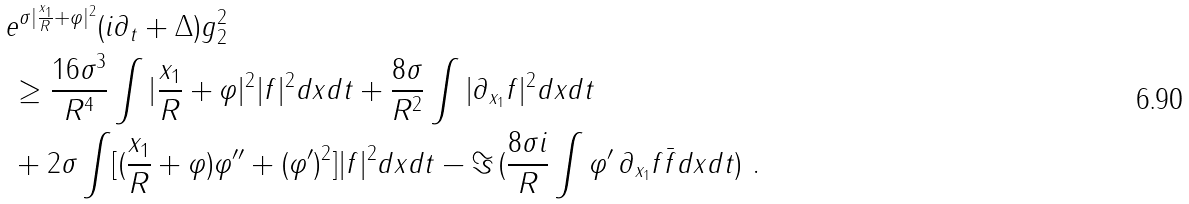Convert formula to latex. <formula><loc_0><loc_0><loc_500><loc_500>& \| e ^ { \sigma | \frac { x _ { 1 } } { R } + \varphi | ^ { 2 } } ( i \partial _ { t } + \Delta ) g \| _ { 2 } ^ { 2 } \\ & \, \geq \frac { 1 6 \sigma ^ { 3 } } { R ^ { 4 } } \int | \frac { x _ { 1 } } { R } + \varphi | ^ { 2 } | f | ^ { 2 } d x d t + \frac { 8 \sigma } { R ^ { 2 } } \int | \partial _ { x _ { 1 } } f | ^ { 2 } d x d t \\ & \, + 2 \sigma \int [ ( \frac { x _ { 1 } } R + \varphi ) \varphi ^ { \prime \prime } + ( \varphi ^ { \prime } ) ^ { 2 } ] | f | ^ { 2 } d x d t - \Im \, ( \frac { 8 \sigma i } R \int \varphi ^ { \prime } \, \partial _ { x _ { 1 } } f \bar { f } d x d t ) \ .</formula> 